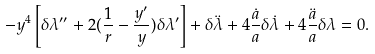Convert formula to latex. <formula><loc_0><loc_0><loc_500><loc_500>- y ^ { 4 } \left [ \delta \lambda ^ { \prime \prime } + 2 ( \frac { 1 } { r } - \frac { y ^ { \prime } } y ) \delta \lambda ^ { \prime } \right ] + \delta \ddot { \lambda } + 4 \frac { \dot { a } } a \delta \dot { \lambda } + 4 \frac { \ddot { a } } a \delta \lambda = 0 .</formula> 